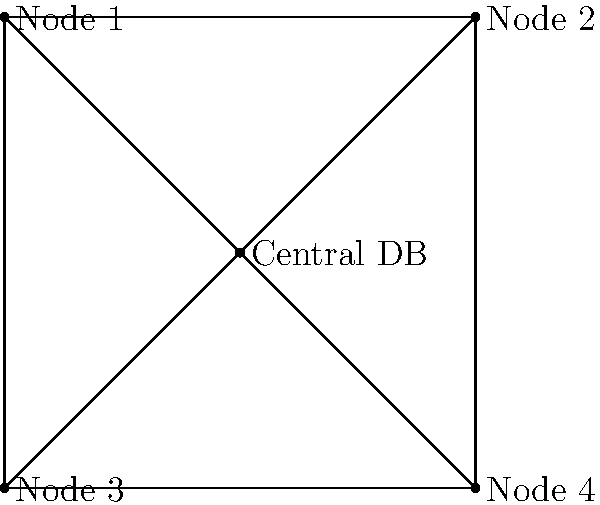In the distributed database architecture shown, which topology is represented, and what are its implications for query processing and data consistency? To answer this question, let's analyze the diagram step-by-step:

1. Central node: There is a central node labeled "Central DB" connected to all other nodes.
2. Peripheral nodes: Four nodes (Node 1, Node 2, Node 3, Node 4) are connected to the central node and each other.
3. Connections: Each peripheral node is connected to the central node and its adjacent nodes.

This topology represents a hybrid between a centralized and a fully distributed architecture, known as a "Hub and Spoke" or "Star" topology with additional interconnections.

Implications for query processing:
1. Centralized queries: The central node can efficiently process queries requiring data from multiple nodes.
2. Local queries: Peripheral nodes can process queries using local data without involving the central node.
3. Load distribution: The central node may become a bottleneck for complex queries involving multiple nodes.

Implications for data consistency:
1. Master-slave replication: The central node can act as the master, with peripheral nodes as slaves, ensuring consistency.
2. Update propagation: Updates can be quickly propagated through the central node to all peripheral nodes.
3. Conflict resolution: The central node can serve as the authority for resolving conflicts in concurrent updates.

This architecture balances the benefits of centralized control with the flexibility of distributed processing, making it suitable for scenarios where both local autonomy and global consistency are required.
Answer: Hub and Spoke topology with interconnections, offering balanced query processing and centralized consistency management. 